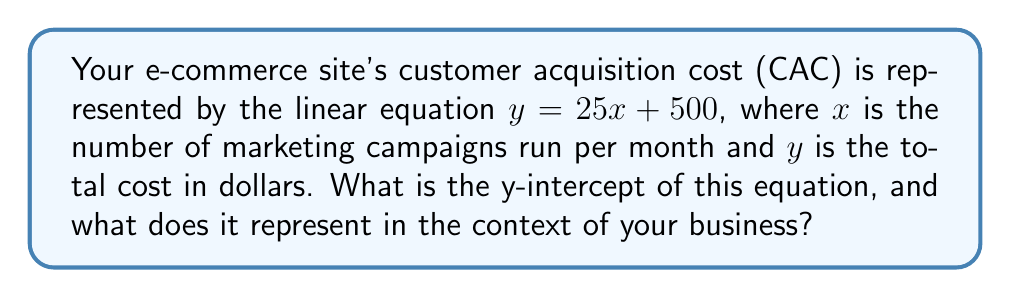Help me with this question. To determine the y-intercept of the given linear equation, we need to follow these steps:

1. Recall that the y-intercept is the point where the line crosses the y-axis. This occurs when $x = 0$.

2. The general form of a linear equation is $y = mx + b$, where $b$ is the y-intercept.

3. In our equation, $y = 25x + 500$, we can identify that:
   $m = 25$ (slope)
   $b = 500$ (y-intercept)

4. Therefore, the y-intercept is 500.

In the context of the e-commerce business:
- The y-intercept represents the fixed cost of customer acquisition when no marketing campaigns are run ($x = 0$).
- This means that even without any marketing campaigns, there's a base cost of $500 for acquiring customers.
- This could represent expenses like website maintenance, basic SEO, or other fixed costs associated with keeping the e-commerce platform operational.
Answer: $500; represents fixed customer acquisition cost 